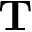<formula> <loc_0><loc_0><loc_500><loc_500>T</formula> 